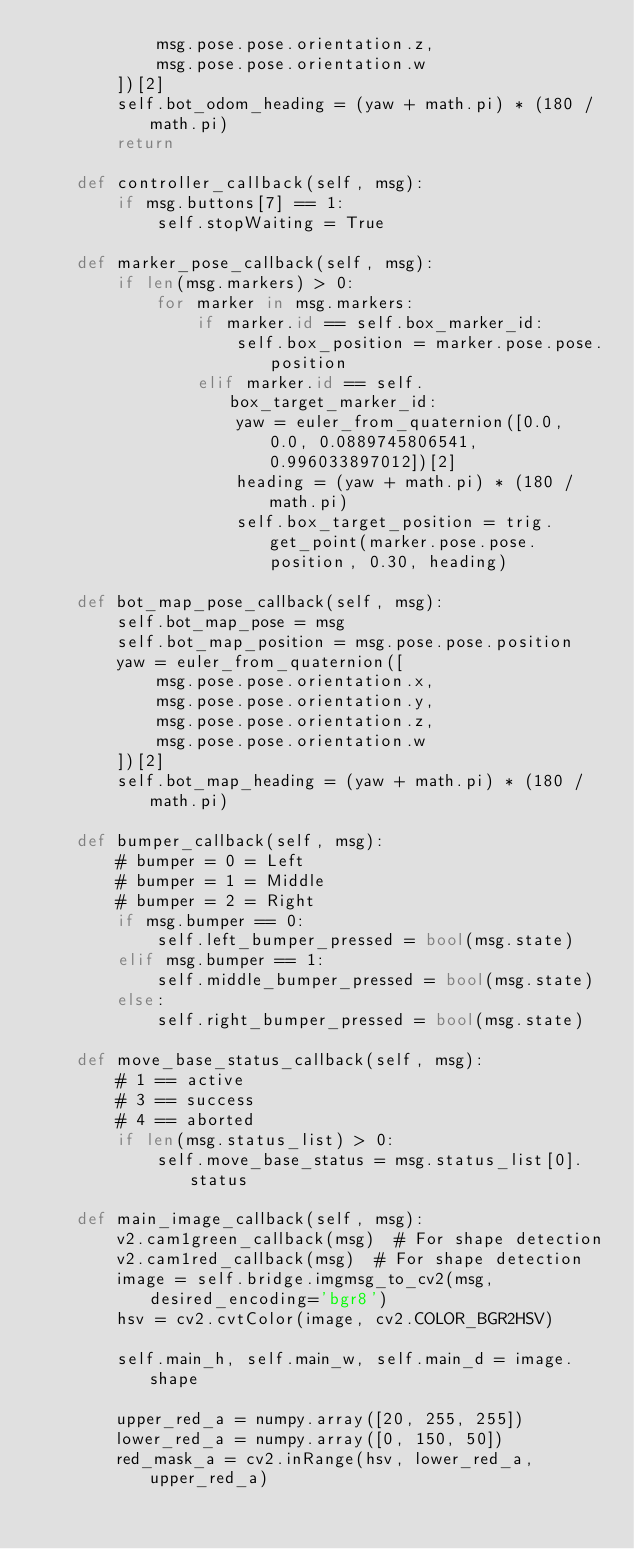<code> <loc_0><loc_0><loc_500><loc_500><_Python_>            msg.pose.pose.orientation.z,
            msg.pose.pose.orientation.w
        ])[2]
        self.bot_odom_heading = (yaw + math.pi) * (180 / math.pi)
        return

    def controller_callback(self, msg):
        if msg.buttons[7] == 1:
            self.stopWaiting = True

    def marker_pose_callback(self, msg):
        if len(msg.markers) > 0:
            for marker in msg.markers:
                if marker.id == self.box_marker_id:
                    self.box_position = marker.pose.pose.position
                elif marker.id == self.box_target_marker_id:
                    yaw = euler_from_quaternion([0.0, 0.0, 0.0889745806541, 0.996033897012])[2]
                    heading = (yaw + math.pi) * (180 / math.pi)
                    self.box_target_position = trig.get_point(marker.pose.pose.position, 0.30, heading)

    def bot_map_pose_callback(self, msg):
        self.bot_map_pose = msg
        self.bot_map_position = msg.pose.pose.position
        yaw = euler_from_quaternion([
            msg.pose.pose.orientation.x,
            msg.pose.pose.orientation.y,
            msg.pose.pose.orientation.z,
            msg.pose.pose.orientation.w
        ])[2]
        self.bot_map_heading = (yaw + math.pi) * (180 / math.pi)

    def bumper_callback(self, msg):
        # bumper = 0 = Left
        # bumper = 1 = Middle
        # bumper = 2 = Right
        if msg.bumper == 0:
            self.left_bumper_pressed = bool(msg.state)
        elif msg.bumper == 1:
            self.middle_bumper_pressed = bool(msg.state)
        else:
            self.right_bumper_pressed = bool(msg.state)

    def move_base_status_callback(self, msg):
        # 1 == active
        # 3 == success
        # 4 == aborted
        if len(msg.status_list) > 0:
            self.move_base_status = msg.status_list[0].status

    def main_image_callback(self, msg):
        v2.cam1green_callback(msg)  # For shape detection
        v2.cam1red_callback(msg)  # For shape detection
        image = self.bridge.imgmsg_to_cv2(msg, desired_encoding='bgr8')
        hsv = cv2.cvtColor(image, cv2.COLOR_BGR2HSV)

        self.main_h, self.main_w, self.main_d = image.shape

        upper_red_a = numpy.array([20, 255, 255])
        lower_red_a = numpy.array([0, 150, 50])
        red_mask_a = cv2.inRange(hsv, lower_red_a, upper_red_a)
</code> 